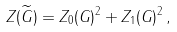Convert formula to latex. <formula><loc_0><loc_0><loc_500><loc_500>Z ( \widetilde { G } ) = Z _ { 0 } ( G ) ^ { 2 } + Z _ { 1 } ( G ) ^ { 2 } \, ,</formula> 